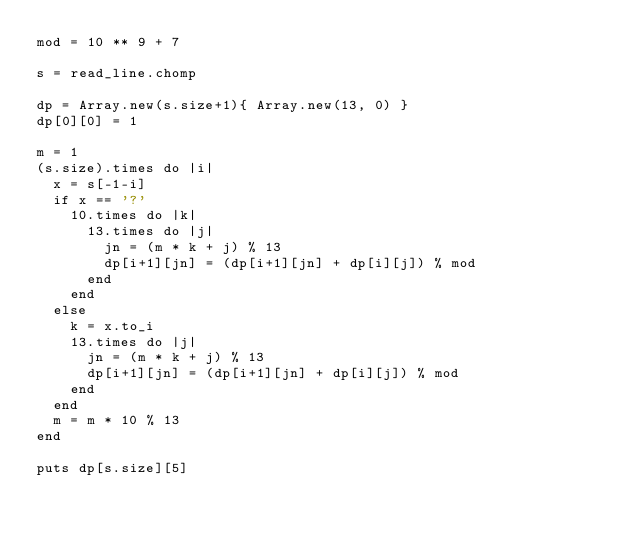<code> <loc_0><loc_0><loc_500><loc_500><_Crystal_>mod = 10 ** 9 + 7

s = read_line.chomp

dp = Array.new(s.size+1){ Array.new(13, 0) }
dp[0][0] = 1

m = 1
(s.size).times do |i|
  x = s[-1-i]
  if x == '?'
    10.times do |k|
      13.times do |j|
        jn = (m * k + j) % 13
        dp[i+1][jn] = (dp[i+1][jn] + dp[i][j]) % mod
      end
    end
  else
    k = x.to_i
    13.times do |j|
      jn = (m * k + j) % 13
      dp[i+1][jn] = (dp[i+1][jn] + dp[i][j]) % mod
    end
  end
  m = m * 10 % 13
end

puts dp[s.size][5]</code> 